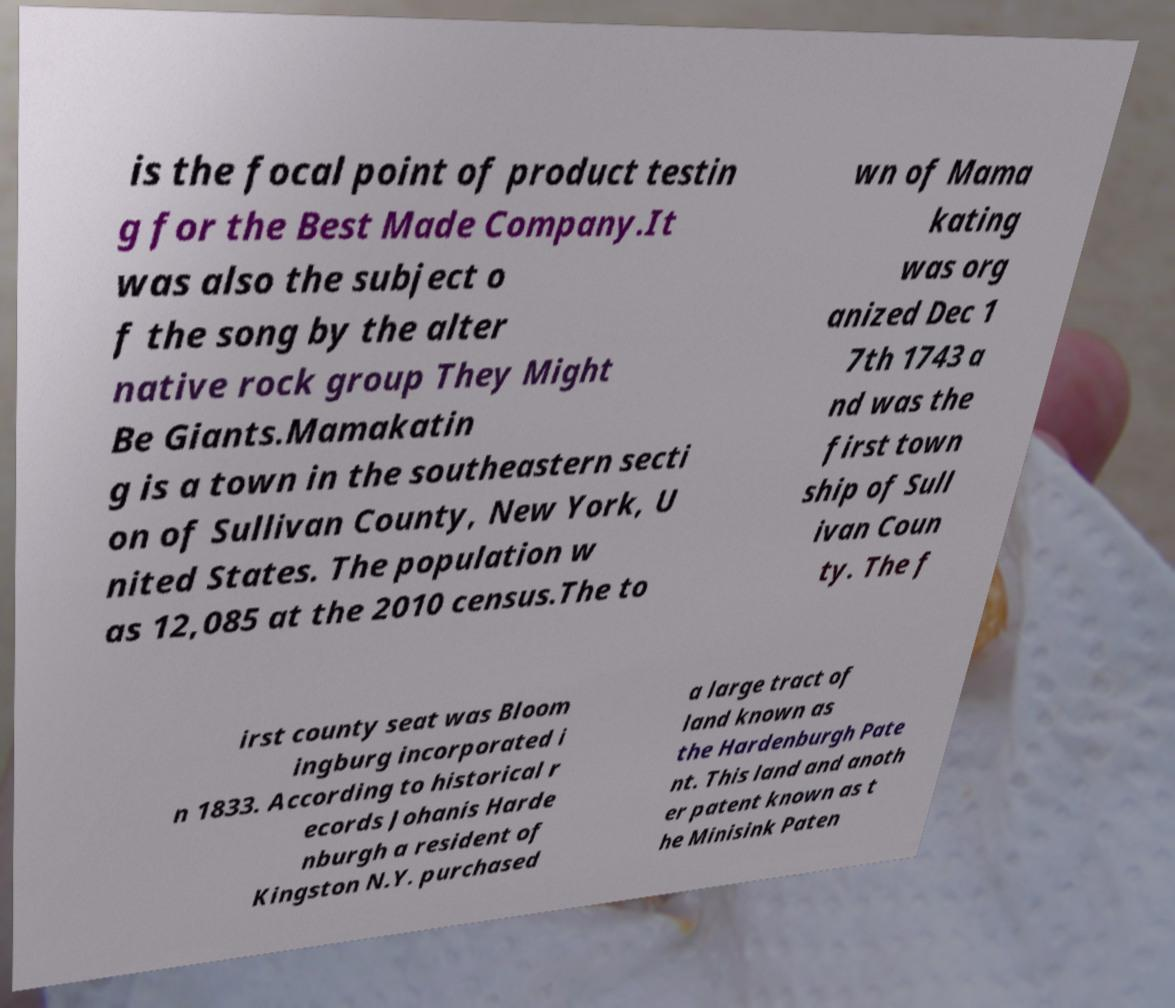What messages or text are displayed in this image? I need them in a readable, typed format. is the focal point of product testin g for the Best Made Company.It was also the subject o f the song by the alter native rock group They Might Be Giants.Mamakatin g is a town in the southeastern secti on of Sullivan County, New York, U nited States. The population w as 12,085 at the 2010 census.The to wn of Mama kating was org anized Dec 1 7th 1743 a nd was the first town ship of Sull ivan Coun ty. The f irst county seat was Bloom ingburg incorporated i n 1833. According to historical r ecords Johanis Harde nburgh a resident of Kingston N.Y. purchased a large tract of land known as the Hardenburgh Pate nt. This land and anoth er patent known as t he Minisink Paten 